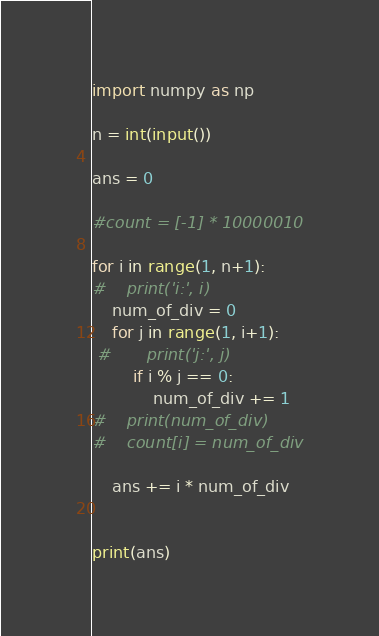Convert code to text. <code><loc_0><loc_0><loc_500><loc_500><_Python_>import numpy as np

n = int(input())

ans = 0

#count = [-1] * 10000010

for i in range(1, n+1):
#    print('i:', i)
    num_of_div = 0
    for j in range(1, i+1):
 #       print('j:', j)
        if i % j == 0:
            num_of_div += 1
#    print(num_of_div)
#    count[i] = num_of_div

    ans += i * num_of_div


print(ans)</code> 